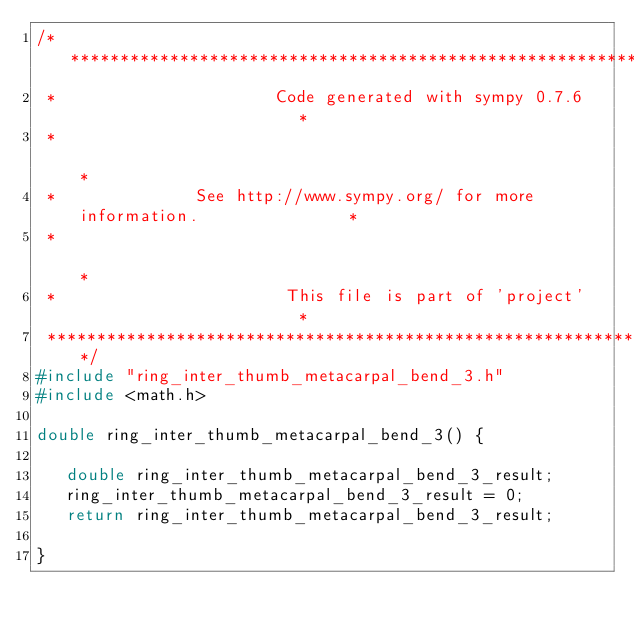<code> <loc_0><loc_0><loc_500><loc_500><_C_>/******************************************************************************
 *                      Code generated with sympy 0.7.6                       *
 *                                                                            *
 *              See http://www.sympy.org/ for more information.               *
 *                                                                            *
 *                       This file is part of 'project'                       *
 ******************************************************************************/
#include "ring_inter_thumb_metacarpal_bend_3.h"
#include <math.h>

double ring_inter_thumb_metacarpal_bend_3() {

   double ring_inter_thumb_metacarpal_bend_3_result;
   ring_inter_thumb_metacarpal_bend_3_result = 0;
   return ring_inter_thumb_metacarpal_bend_3_result;

}
</code> 